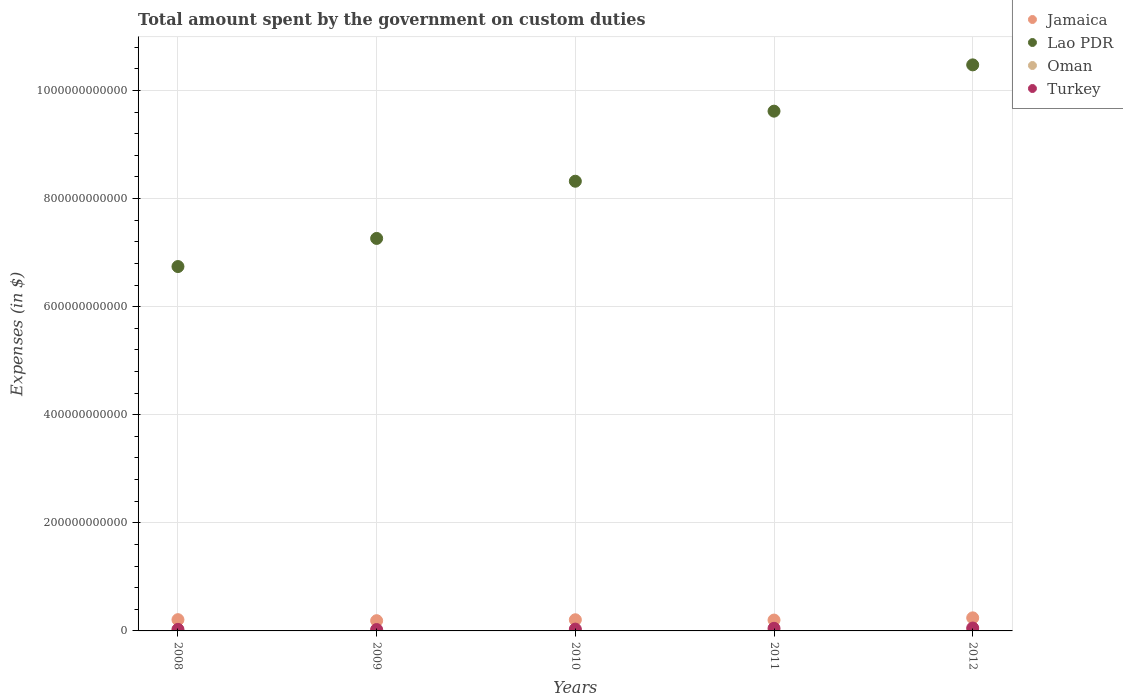How many different coloured dotlines are there?
Make the answer very short. 4. Is the number of dotlines equal to the number of legend labels?
Your answer should be very brief. Yes. What is the amount spent on custom duties by the government in Lao PDR in 2009?
Your answer should be compact. 7.26e+11. Across all years, what is the maximum amount spent on custom duties by the government in Jamaica?
Your answer should be compact. 2.42e+1. Across all years, what is the minimum amount spent on custom duties by the government in Oman?
Provide a succinct answer. 1.58e+08. In which year was the amount spent on custom duties by the government in Lao PDR maximum?
Your response must be concise. 2012. In which year was the amount spent on custom duties by the government in Oman minimum?
Your response must be concise. 2009. What is the total amount spent on custom duties by the government in Lao PDR in the graph?
Ensure brevity in your answer.  4.24e+12. What is the difference between the amount spent on custom duties by the government in Oman in 2008 and that in 2010?
Offer a terse response. 4.70e+07. What is the difference between the amount spent on custom duties by the government in Turkey in 2011 and the amount spent on custom duties by the government in Lao PDR in 2012?
Make the answer very short. -1.04e+12. What is the average amount spent on custom duties by the government in Oman per year?
Your answer should be compact. 1.95e+08. In the year 2008, what is the difference between the amount spent on custom duties by the government in Oman and amount spent on custom duties by the government in Lao PDR?
Provide a succinct answer. -6.74e+11. In how many years, is the amount spent on custom duties by the government in Jamaica greater than 880000000000 $?
Provide a short and direct response. 0. What is the ratio of the amount spent on custom duties by the government in Oman in 2009 to that in 2012?
Your answer should be very brief. 0.63. What is the difference between the highest and the second highest amount spent on custom duties by the government in Turkey?
Provide a succinct answer. 5.47e+08. What is the difference between the highest and the lowest amount spent on custom duties by the government in Jamaica?
Your response must be concise. 5.24e+09. How many years are there in the graph?
Ensure brevity in your answer.  5. What is the difference between two consecutive major ticks on the Y-axis?
Ensure brevity in your answer.  2.00e+11. How many legend labels are there?
Offer a terse response. 4. What is the title of the graph?
Offer a terse response. Total amount spent by the government on custom duties. What is the label or title of the Y-axis?
Provide a short and direct response. Expenses (in $). What is the Expenses (in $) of Jamaica in 2008?
Your response must be concise. 2.08e+1. What is the Expenses (in $) in Lao PDR in 2008?
Your response must be concise. 6.74e+11. What is the Expenses (in $) in Oman in 2008?
Give a very brief answer. 2.27e+08. What is the Expenses (in $) in Turkey in 2008?
Keep it short and to the point. 2.87e+09. What is the Expenses (in $) of Jamaica in 2009?
Your answer should be very brief. 1.89e+1. What is the Expenses (in $) of Lao PDR in 2009?
Ensure brevity in your answer.  7.26e+11. What is the Expenses (in $) of Oman in 2009?
Keep it short and to the point. 1.58e+08. What is the Expenses (in $) in Turkey in 2009?
Offer a terse response. 2.56e+09. What is the Expenses (in $) of Jamaica in 2010?
Offer a terse response. 2.06e+1. What is the Expenses (in $) in Lao PDR in 2010?
Offer a very short reply. 8.32e+11. What is the Expenses (in $) in Oman in 2010?
Offer a terse response. 1.80e+08. What is the Expenses (in $) in Turkey in 2010?
Your answer should be very brief. 3.36e+09. What is the Expenses (in $) in Jamaica in 2011?
Your response must be concise. 2.01e+1. What is the Expenses (in $) in Lao PDR in 2011?
Your answer should be very brief. 9.62e+11. What is the Expenses (in $) in Oman in 2011?
Ensure brevity in your answer.  1.61e+08. What is the Expenses (in $) in Turkey in 2011?
Your response must be concise. 4.82e+09. What is the Expenses (in $) in Jamaica in 2012?
Make the answer very short. 2.42e+1. What is the Expenses (in $) in Lao PDR in 2012?
Offer a very short reply. 1.05e+12. What is the Expenses (in $) in Oman in 2012?
Your response must be concise. 2.50e+08. What is the Expenses (in $) of Turkey in 2012?
Keep it short and to the point. 5.37e+09. Across all years, what is the maximum Expenses (in $) in Jamaica?
Provide a short and direct response. 2.42e+1. Across all years, what is the maximum Expenses (in $) of Lao PDR?
Your answer should be compact. 1.05e+12. Across all years, what is the maximum Expenses (in $) in Oman?
Your response must be concise. 2.50e+08. Across all years, what is the maximum Expenses (in $) of Turkey?
Your answer should be very brief. 5.37e+09. Across all years, what is the minimum Expenses (in $) of Jamaica?
Provide a short and direct response. 1.89e+1. Across all years, what is the minimum Expenses (in $) in Lao PDR?
Give a very brief answer. 6.74e+11. Across all years, what is the minimum Expenses (in $) in Oman?
Provide a short and direct response. 1.58e+08. Across all years, what is the minimum Expenses (in $) in Turkey?
Give a very brief answer. 2.56e+09. What is the total Expenses (in $) of Jamaica in the graph?
Your response must be concise. 1.05e+11. What is the total Expenses (in $) in Lao PDR in the graph?
Make the answer very short. 4.24e+12. What is the total Expenses (in $) of Oman in the graph?
Ensure brevity in your answer.  9.76e+08. What is the total Expenses (in $) in Turkey in the graph?
Provide a succinct answer. 1.90e+1. What is the difference between the Expenses (in $) in Jamaica in 2008 and that in 2009?
Ensure brevity in your answer.  1.89e+09. What is the difference between the Expenses (in $) of Lao PDR in 2008 and that in 2009?
Make the answer very short. -5.20e+1. What is the difference between the Expenses (in $) of Oman in 2008 and that in 2009?
Ensure brevity in your answer.  6.85e+07. What is the difference between the Expenses (in $) of Turkey in 2008 and that in 2009?
Give a very brief answer. 3.18e+08. What is the difference between the Expenses (in $) of Jamaica in 2008 and that in 2010?
Give a very brief answer. 1.80e+08. What is the difference between the Expenses (in $) of Lao PDR in 2008 and that in 2010?
Your answer should be compact. -1.58e+11. What is the difference between the Expenses (in $) of Oman in 2008 and that in 2010?
Your answer should be compact. 4.70e+07. What is the difference between the Expenses (in $) in Turkey in 2008 and that in 2010?
Keep it short and to the point. -4.83e+08. What is the difference between the Expenses (in $) in Jamaica in 2008 and that in 2011?
Your answer should be compact. 7.50e+08. What is the difference between the Expenses (in $) in Lao PDR in 2008 and that in 2011?
Keep it short and to the point. -2.88e+11. What is the difference between the Expenses (in $) of Oman in 2008 and that in 2011?
Offer a very short reply. 6.54e+07. What is the difference between the Expenses (in $) of Turkey in 2008 and that in 2011?
Offer a terse response. -1.95e+09. What is the difference between the Expenses (in $) in Jamaica in 2008 and that in 2012?
Keep it short and to the point. -3.35e+09. What is the difference between the Expenses (in $) in Lao PDR in 2008 and that in 2012?
Your response must be concise. -3.73e+11. What is the difference between the Expenses (in $) of Oman in 2008 and that in 2012?
Offer a very short reply. -2.35e+07. What is the difference between the Expenses (in $) of Turkey in 2008 and that in 2012?
Make the answer very short. -2.49e+09. What is the difference between the Expenses (in $) of Jamaica in 2009 and that in 2010?
Offer a terse response. -1.71e+09. What is the difference between the Expenses (in $) of Lao PDR in 2009 and that in 2010?
Offer a terse response. -1.06e+11. What is the difference between the Expenses (in $) of Oman in 2009 and that in 2010?
Give a very brief answer. -2.15e+07. What is the difference between the Expenses (in $) of Turkey in 2009 and that in 2010?
Your answer should be compact. -8.01e+08. What is the difference between the Expenses (in $) in Jamaica in 2009 and that in 2011?
Provide a succinct answer. -1.14e+09. What is the difference between the Expenses (in $) of Lao PDR in 2009 and that in 2011?
Offer a terse response. -2.35e+11. What is the difference between the Expenses (in $) of Oman in 2009 and that in 2011?
Make the answer very short. -3.10e+06. What is the difference between the Expenses (in $) in Turkey in 2009 and that in 2011?
Offer a terse response. -2.27e+09. What is the difference between the Expenses (in $) of Jamaica in 2009 and that in 2012?
Keep it short and to the point. -5.24e+09. What is the difference between the Expenses (in $) in Lao PDR in 2009 and that in 2012?
Your answer should be compact. -3.21e+11. What is the difference between the Expenses (in $) of Oman in 2009 and that in 2012?
Keep it short and to the point. -9.20e+07. What is the difference between the Expenses (in $) in Turkey in 2009 and that in 2012?
Make the answer very short. -2.81e+09. What is the difference between the Expenses (in $) of Jamaica in 2010 and that in 2011?
Make the answer very short. 5.70e+08. What is the difference between the Expenses (in $) in Lao PDR in 2010 and that in 2011?
Make the answer very short. -1.30e+11. What is the difference between the Expenses (in $) in Oman in 2010 and that in 2011?
Your answer should be very brief. 1.84e+07. What is the difference between the Expenses (in $) in Turkey in 2010 and that in 2011?
Make the answer very short. -1.46e+09. What is the difference between the Expenses (in $) in Jamaica in 2010 and that in 2012?
Your response must be concise. -3.53e+09. What is the difference between the Expenses (in $) in Lao PDR in 2010 and that in 2012?
Offer a terse response. -2.15e+11. What is the difference between the Expenses (in $) of Oman in 2010 and that in 2012?
Your answer should be compact. -7.05e+07. What is the difference between the Expenses (in $) of Turkey in 2010 and that in 2012?
Keep it short and to the point. -2.01e+09. What is the difference between the Expenses (in $) in Jamaica in 2011 and that in 2012?
Provide a short and direct response. -4.10e+09. What is the difference between the Expenses (in $) in Lao PDR in 2011 and that in 2012?
Make the answer very short. -8.56e+1. What is the difference between the Expenses (in $) in Oman in 2011 and that in 2012?
Keep it short and to the point. -8.89e+07. What is the difference between the Expenses (in $) of Turkey in 2011 and that in 2012?
Your answer should be very brief. -5.47e+08. What is the difference between the Expenses (in $) in Jamaica in 2008 and the Expenses (in $) in Lao PDR in 2009?
Give a very brief answer. -7.05e+11. What is the difference between the Expenses (in $) of Jamaica in 2008 and the Expenses (in $) of Oman in 2009?
Make the answer very short. 2.07e+1. What is the difference between the Expenses (in $) in Jamaica in 2008 and the Expenses (in $) in Turkey in 2009?
Your answer should be very brief. 1.83e+1. What is the difference between the Expenses (in $) of Lao PDR in 2008 and the Expenses (in $) of Oman in 2009?
Offer a very short reply. 6.74e+11. What is the difference between the Expenses (in $) in Lao PDR in 2008 and the Expenses (in $) in Turkey in 2009?
Your answer should be compact. 6.72e+11. What is the difference between the Expenses (in $) in Oman in 2008 and the Expenses (in $) in Turkey in 2009?
Provide a short and direct response. -2.33e+09. What is the difference between the Expenses (in $) in Jamaica in 2008 and the Expenses (in $) in Lao PDR in 2010?
Offer a terse response. -8.11e+11. What is the difference between the Expenses (in $) in Jamaica in 2008 and the Expenses (in $) in Oman in 2010?
Make the answer very short. 2.06e+1. What is the difference between the Expenses (in $) in Jamaica in 2008 and the Expenses (in $) in Turkey in 2010?
Your answer should be compact. 1.75e+1. What is the difference between the Expenses (in $) of Lao PDR in 2008 and the Expenses (in $) of Oman in 2010?
Your response must be concise. 6.74e+11. What is the difference between the Expenses (in $) in Lao PDR in 2008 and the Expenses (in $) in Turkey in 2010?
Provide a short and direct response. 6.71e+11. What is the difference between the Expenses (in $) in Oman in 2008 and the Expenses (in $) in Turkey in 2010?
Provide a succinct answer. -3.13e+09. What is the difference between the Expenses (in $) of Jamaica in 2008 and the Expenses (in $) of Lao PDR in 2011?
Provide a succinct answer. -9.41e+11. What is the difference between the Expenses (in $) of Jamaica in 2008 and the Expenses (in $) of Oman in 2011?
Make the answer very short. 2.07e+1. What is the difference between the Expenses (in $) of Jamaica in 2008 and the Expenses (in $) of Turkey in 2011?
Offer a very short reply. 1.60e+1. What is the difference between the Expenses (in $) in Lao PDR in 2008 and the Expenses (in $) in Oman in 2011?
Keep it short and to the point. 6.74e+11. What is the difference between the Expenses (in $) in Lao PDR in 2008 and the Expenses (in $) in Turkey in 2011?
Your response must be concise. 6.69e+11. What is the difference between the Expenses (in $) of Oman in 2008 and the Expenses (in $) of Turkey in 2011?
Give a very brief answer. -4.59e+09. What is the difference between the Expenses (in $) of Jamaica in 2008 and the Expenses (in $) of Lao PDR in 2012?
Provide a succinct answer. -1.03e+12. What is the difference between the Expenses (in $) of Jamaica in 2008 and the Expenses (in $) of Oman in 2012?
Your answer should be compact. 2.06e+1. What is the difference between the Expenses (in $) of Jamaica in 2008 and the Expenses (in $) of Turkey in 2012?
Provide a short and direct response. 1.55e+1. What is the difference between the Expenses (in $) of Lao PDR in 2008 and the Expenses (in $) of Oman in 2012?
Provide a succinct answer. 6.74e+11. What is the difference between the Expenses (in $) of Lao PDR in 2008 and the Expenses (in $) of Turkey in 2012?
Offer a very short reply. 6.69e+11. What is the difference between the Expenses (in $) in Oman in 2008 and the Expenses (in $) in Turkey in 2012?
Offer a terse response. -5.14e+09. What is the difference between the Expenses (in $) of Jamaica in 2009 and the Expenses (in $) of Lao PDR in 2010?
Your answer should be compact. -8.13e+11. What is the difference between the Expenses (in $) in Jamaica in 2009 and the Expenses (in $) in Oman in 2010?
Ensure brevity in your answer.  1.88e+1. What is the difference between the Expenses (in $) of Jamaica in 2009 and the Expenses (in $) of Turkey in 2010?
Provide a succinct answer. 1.56e+1. What is the difference between the Expenses (in $) of Lao PDR in 2009 and the Expenses (in $) of Oman in 2010?
Your response must be concise. 7.26e+11. What is the difference between the Expenses (in $) of Lao PDR in 2009 and the Expenses (in $) of Turkey in 2010?
Ensure brevity in your answer.  7.23e+11. What is the difference between the Expenses (in $) in Oman in 2009 and the Expenses (in $) in Turkey in 2010?
Keep it short and to the point. -3.20e+09. What is the difference between the Expenses (in $) in Jamaica in 2009 and the Expenses (in $) in Lao PDR in 2011?
Give a very brief answer. -9.43e+11. What is the difference between the Expenses (in $) of Jamaica in 2009 and the Expenses (in $) of Oman in 2011?
Keep it short and to the point. 1.88e+1. What is the difference between the Expenses (in $) in Jamaica in 2009 and the Expenses (in $) in Turkey in 2011?
Your response must be concise. 1.41e+1. What is the difference between the Expenses (in $) in Lao PDR in 2009 and the Expenses (in $) in Oman in 2011?
Give a very brief answer. 7.26e+11. What is the difference between the Expenses (in $) of Lao PDR in 2009 and the Expenses (in $) of Turkey in 2011?
Ensure brevity in your answer.  7.21e+11. What is the difference between the Expenses (in $) in Oman in 2009 and the Expenses (in $) in Turkey in 2011?
Provide a short and direct response. -4.66e+09. What is the difference between the Expenses (in $) in Jamaica in 2009 and the Expenses (in $) in Lao PDR in 2012?
Provide a short and direct response. -1.03e+12. What is the difference between the Expenses (in $) of Jamaica in 2009 and the Expenses (in $) of Oman in 2012?
Offer a very short reply. 1.87e+1. What is the difference between the Expenses (in $) of Jamaica in 2009 and the Expenses (in $) of Turkey in 2012?
Provide a short and direct response. 1.36e+1. What is the difference between the Expenses (in $) in Lao PDR in 2009 and the Expenses (in $) in Oman in 2012?
Keep it short and to the point. 7.26e+11. What is the difference between the Expenses (in $) in Lao PDR in 2009 and the Expenses (in $) in Turkey in 2012?
Provide a succinct answer. 7.21e+11. What is the difference between the Expenses (in $) of Oman in 2009 and the Expenses (in $) of Turkey in 2012?
Your response must be concise. -5.21e+09. What is the difference between the Expenses (in $) in Jamaica in 2010 and the Expenses (in $) in Lao PDR in 2011?
Offer a terse response. -9.41e+11. What is the difference between the Expenses (in $) of Jamaica in 2010 and the Expenses (in $) of Oman in 2011?
Give a very brief answer. 2.05e+1. What is the difference between the Expenses (in $) of Jamaica in 2010 and the Expenses (in $) of Turkey in 2011?
Provide a succinct answer. 1.58e+1. What is the difference between the Expenses (in $) of Lao PDR in 2010 and the Expenses (in $) of Oman in 2011?
Offer a terse response. 8.32e+11. What is the difference between the Expenses (in $) in Lao PDR in 2010 and the Expenses (in $) in Turkey in 2011?
Provide a succinct answer. 8.27e+11. What is the difference between the Expenses (in $) of Oman in 2010 and the Expenses (in $) of Turkey in 2011?
Your answer should be very brief. -4.64e+09. What is the difference between the Expenses (in $) of Jamaica in 2010 and the Expenses (in $) of Lao PDR in 2012?
Ensure brevity in your answer.  -1.03e+12. What is the difference between the Expenses (in $) in Jamaica in 2010 and the Expenses (in $) in Oman in 2012?
Provide a short and direct response. 2.04e+1. What is the difference between the Expenses (in $) of Jamaica in 2010 and the Expenses (in $) of Turkey in 2012?
Your response must be concise. 1.53e+1. What is the difference between the Expenses (in $) of Lao PDR in 2010 and the Expenses (in $) of Oman in 2012?
Make the answer very short. 8.32e+11. What is the difference between the Expenses (in $) in Lao PDR in 2010 and the Expenses (in $) in Turkey in 2012?
Ensure brevity in your answer.  8.27e+11. What is the difference between the Expenses (in $) in Oman in 2010 and the Expenses (in $) in Turkey in 2012?
Provide a succinct answer. -5.19e+09. What is the difference between the Expenses (in $) of Jamaica in 2011 and the Expenses (in $) of Lao PDR in 2012?
Your answer should be very brief. -1.03e+12. What is the difference between the Expenses (in $) in Jamaica in 2011 and the Expenses (in $) in Oman in 2012?
Your response must be concise. 1.98e+1. What is the difference between the Expenses (in $) of Jamaica in 2011 and the Expenses (in $) of Turkey in 2012?
Provide a succinct answer. 1.47e+1. What is the difference between the Expenses (in $) in Lao PDR in 2011 and the Expenses (in $) in Oman in 2012?
Your response must be concise. 9.61e+11. What is the difference between the Expenses (in $) of Lao PDR in 2011 and the Expenses (in $) of Turkey in 2012?
Offer a very short reply. 9.56e+11. What is the difference between the Expenses (in $) in Oman in 2011 and the Expenses (in $) in Turkey in 2012?
Provide a short and direct response. -5.21e+09. What is the average Expenses (in $) of Jamaica per year?
Ensure brevity in your answer.  2.09e+1. What is the average Expenses (in $) of Lao PDR per year?
Your answer should be compact. 8.48e+11. What is the average Expenses (in $) in Oman per year?
Your answer should be compact. 1.95e+08. What is the average Expenses (in $) in Turkey per year?
Offer a very short reply. 3.79e+09. In the year 2008, what is the difference between the Expenses (in $) in Jamaica and Expenses (in $) in Lao PDR?
Your answer should be very brief. -6.53e+11. In the year 2008, what is the difference between the Expenses (in $) in Jamaica and Expenses (in $) in Oman?
Your answer should be compact. 2.06e+1. In the year 2008, what is the difference between the Expenses (in $) of Jamaica and Expenses (in $) of Turkey?
Ensure brevity in your answer.  1.79e+1. In the year 2008, what is the difference between the Expenses (in $) in Lao PDR and Expenses (in $) in Oman?
Offer a terse response. 6.74e+11. In the year 2008, what is the difference between the Expenses (in $) in Lao PDR and Expenses (in $) in Turkey?
Make the answer very short. 6.71e+11. In the year 2008, what is the difference between the Expenses (in $) in Oman and Expenses (in $) in Turkey?
Provide a succinct answer. -2.65e+09. In the year 2009, what is the difference between the Expenses (in $) of Jamaica and Expenses (in $) of Lao PDR?
Your response must be concise. -7.07e+11. In the year 2009, what is the difference between the Expenses (in $) in Jamaica and Expenses (in $) in Oman?
Provide a short and direct response. 1.88e+1. In the year 2009, what is the difference between the Expenses (in $) in Jamaica and Expenses (in $) in Turkey?
Provide a short and direct response. 1.64e+1. In the year 2009, what is the difference between the Expenses (in $) of Lao PDR and Expenses (in $) of Oman?
Offer a very short reply. 7.26e+11. In the year 2009, what is the difference between the Expenses (in $) in Lao PDR and Expenses (in $) in Turkey?
Keep it short and to the point. 7.24e+11. In the year 2009, what is the difference between the Expenses (in $) of Oman and Expenses (in $) of Turkey?
Your answer should be very brief. -2.40e+09. In the year 2010, what is the difference between the Expenses (in $) in Jamaica and Expenses (in $) in Lao PDR?
Your answer should be very brief. -8.11e+11. In the year 2010, what is the difference between the Expenses (in $) of Jamaica and Expenses (in $) of Oman?
Offer a terse response. 2.05e+1. In the year 2010, what is the difference between the Expenses (in $) in Jamaica and Expenses (in $) in Turkey?
Your answer should be compact. 1.73e+1. In the year 2010, what is the difference between the Expenses (in $) in Lao PDR and Expenses (in $) in Oman?
Your response must be concise. 8.32e+11. In the year 2010, what is the difference between the Expenses (in $) in Lao PDR and Expenses (in $) in Turkey?
Offer a terse response. 8.29e+11. In the year 2010, what is the difference between the Expenses (in $) in Oman and Expenses (in $) in Turkey?
Your answer should be compact. -3.18e+09. In the year 2011, what is the difference between the Expenses (in $) in Jamaica and Expenses (in $) in Lao PDR?
Your answer should be very brief. -9.42e+11. In the year 2011, what is the difference between the Expenses (in $) of Jamaica and Expenses (in $) of Oman?
Your answer should be compact. 1.99e+1. In the year 2011, what is the difference between the Expenses (in $) of Jamaica and Expenses (in $) of Turkey?
Your answer should be compact. 1.53e+1. In the year 2011, what is the difference between the Expenses (in $) of Lao PDR and Expenses (in $) of Oman?
Your answer should be very brief. 9.62e+11. In the year 2011, what is the difference between the Expenses (in $) of Lao PDR and Expenses (in $) of Turkey?
Offer a very short reply. 9.57e+11. In the year 2011, what is the difference between the Expenses (in $) in Oman and Expenses (in $) in Turkey?
Offer a terse response. -4.66e+09. In the year 2012, what is the difference between the Expenses (in $) in Jamaica and Expenses (in $) in Lao PDR?
Offer a terse response. -1.02e+12. In the year 2012, what is the difference between the Expenses (in $) of Jamaica and Expenses (in $) of Oman?
Your answer should be compact. 2.39e+1. In the year 2012, what is the difference between the Expenses (in $) in Jamaica and Expenses (in $) in Turkey?
Provide a succinct answer. 1.88e+1. In the year 2012, what is the difference between the Expenses (in $) in Lao PDR and Expenses (in $) in Oman?
Your answer should be compact. 1.05e+12. In the year 2012, what is the difference between the Expenses (in $) of Lao PDR and Expenses (in $) of Turkey?
Your answer should be very brief. 1.04e+12. In the year 2012, what is the difference between the Expenses (in $) of Oman and Expenses (in $) of Turkey?
Your response must be concise. -5.12e+09. What is the ratio of the Expenses (in $) in Jamaica in 2008 to that in 2009?
Your response must be concise. 1.1. What is the ratio of the Expenses (in $) of Lao PDR in 2008 to that in 2009?
Your answer should be compact. 0.93. What is the ratio of the Expenses (in $) in Oman in 2008 to that in 2009?
Keep it short and to the point. 1.43. What is the ratio of the Expenses (in $) in Turkey in 2008 to that in 2009?
Offer a very short reply. 1.12. What is the ratio of the Expenses (in $) in Jamaica in 2008 to that in 2010?
Your answer should be compact. 1.01. What is the ratio of the Expenses (in $) in Lao PDR in 2008 to that in 2010?
Offer a very short reply. 0.81. What is the ratio of the Expenses (in $) of Oman in 2008 to that in 2010?
Keep it short and to the point. 1.26. What is the ratio of the Expenses (in $) in Turkey in 2008 to that in 2010?
Provide a short and direct response. 0.86. What is the ratio of the Expenses (in $) of Jamaica in 2008 to that in 2011?
Your answer should be compact. 1.04. What is the ratio of the Expenses (in $) in Lao PDR in 2008 to that in 2011?
Provide a short and direct response. 0.7. What is the ratio of the Expenses (in $) of Oman in 2008 to that in 2011?
Offer a very short reply. 1.41. What is the ratio of the Expenses (in $) in Turkey in 2008 to that in 2011?
Provide a succinct answer. 0.6. What is the ratio of the Expenses (in $) of Jamaica in 2008 to that in 2012?
Make the answer very short. 0.86. What is the ratio of the Expenses (in $) in Lao PDR in 2008 to that in 2012?
Your answer should be compact. 0.64. What is the ratio of the Expenses (in $) in Oman in 2008 to that in 2012?
Offer a terse response. 0.91. What is the ratio of the Expenses (in $) of Turkey in 2008 to that in 2012?
Your answer should be compact. 0.54. What is the ratio of the Expenses (in $) of Jamaica in 2009 to that in 2010?
Offer a very short reply. 0.92. What is the ratio of the Expenses (in $) of Lao PDR in 2009 to that in 2010?
Your answer should be very brief. 0.87. What is the ratio of the Expenses (in $) in Oman in 2009 to that in 2010?
Give a very brief answer. 0.88. What is the ratio of the Expenses (in $) of Turkey in 2009 to that in 2010?
Your answer should be very brief. 0.76. What is the ratio of the Expenses (in $) of Jamaica in 2009 to that in 2011?
Ensure brevity in your answer.  0.94. What is the ratio of the Expenses (in $) in Lao PDR in 2009 to that in 2011?
Make the answer very short. 0.76. What is the ratio of the Expenses (in $) of Oman in 2009 to that in 2011?
Provide a short and direct response. 0.98. What is the ratio of the Expenses (in $) in Turkey in 2009 to that in 2011?
Your answer should be compact. 0.53. What is the ratio of the Expenses (in $) in Jamaica in 2009 to that in 2012?
Give a very brief answer. 0.78. What is the ratio of the Expenses (in $) in Lao PDR in 2009 to that in 2012?
Your answer should be very brief. 0.69. What is the ratio of the Expenses (in $) of Oman in 2009 to that in 2012?
Provide a short and direct response. 0.63. What is the ratio of the Expenses (in $) in Turkey in 2009 to that in 2012?
Make the answer very short. 0.48. What is the ratio of the Expenses (in $) in Jamaica in 2010 to that in 2011?
Make the answer very short. 1.03. What is the ratio of the Expenses (in $) in Lao PDR in 2010 to that in 2011?
Offer a terse response. 0.87. What is the ratio of the Expenses (in $) in Oman in 2010 to that in 2011?
Your answer should be very brief. 1.11. What is the ratio of the Expenses (in $) of Turkey in 2010 to that in 2011?
Your response must be concise. 0.7. What is the ratio of the Expenses (in $) of Jamaica in 2010 to that in 2012?
Your answer should be compact. 0.85. What is the ratio of the Expenses (in $) in Lao PDR in 2010 to that in 2012?
Offer a very short reply. 0.79. What is the ratio of the Expenses (in $) of Oman in 2010 to that in 2012?
Your answer should be compact. 0.72. What is the ratio of the Expenses (in $) of Turkey in 2010 to that in 2012?
Offer a terse response. 0.63. What is the ratio of the Expenses (in $) of Jamaica in 2011 to that in 2012?
Provide a succinct answer. 0.83. What is the ratio of the Expenses (in $) of Lao PDR in 2011 to that in 2012?
Provide a succinct answer. 0.92. What is the ratio of the Expenses (in $) in Oman in 2011 to that in 2012?
Your answer should be compact. 0.64. What is the ratio of the Expenses (in $) in Turkey in 2011 to that in 2012?
Ensure brevity in your answer.  0.9. What is the difference between the highest and the second highest Expenses (in $) of Jamaica?
Offer a very short reply. 3.35e+09. What is the difference between the highest and the second highest Expenses (in $) of Lao PDR?
Offer a very short reply. 8.56e+1. What is the difference between the highest and the second highest Expenses (in $) in Oman?
Keep it short and to the point. 2.35e+07. What is the difference between the highest and the second highest Expenses (in $) in Turkey?
Your response must be concise. 5.47e+08. What is the difference between the highest and the lowest Expenses (in $) in Jamaica?
Make the answer very short. 5.24e+09. What is the difference between the highest and the lowest Expenses (in $) in Lao PDR?
Give a very brief answer. 3.73e+11. What is the difference between the highest and the lowest Expenses (in $) of Oman?
Provide a succinct answer. 9.20e+07. What is the difference between the highest and the lowest Expenses (in $) of Turkey?
Your response must be concise. 2.81e+09. 